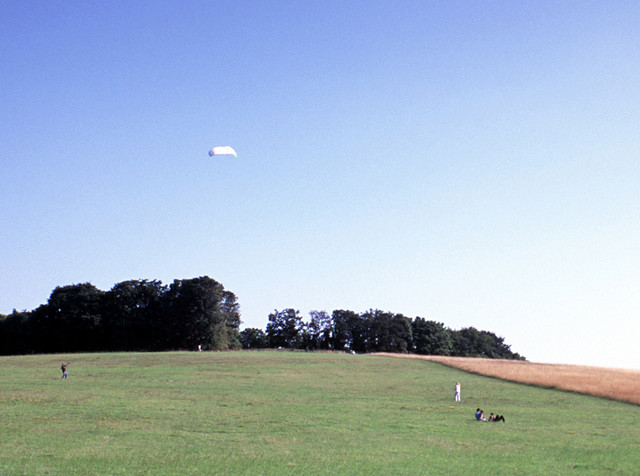How would you describe the weather in this image? The weather appears to be quite favorable with clear blue skies and abundant sunshine. The visibility is high and there are no signs of precipitation, which suggests a perfect day for outdoor activities. 